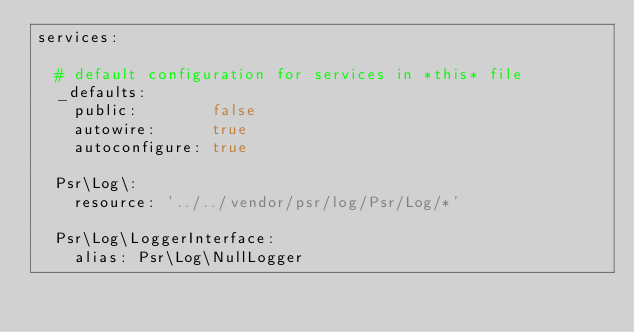Convert code to text. <code><loc_0><loc_0><loc_500><loc_500><_YAML_>services:

  # default configuration for services in *this* file
  _defaults:
    public:        false
    autowire:      true
    autoconfigure: true

  Psr\Log\:
    resource: '../../vendor/psr/log/Psr/Log/*'

  Psr\Log\LoggerInterface:
    alias: Psr\Log\NullLogger
</code> 